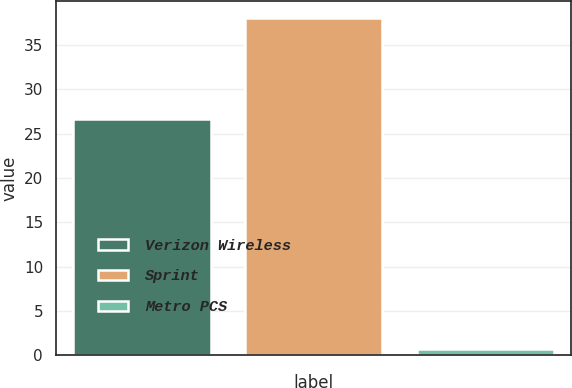Convert chart to OTSL. <chart><loc_0><loc_0><loc_500><loc_500><bar_chart><fcel>Verizon Wireless<fcel>Sprint<fcel>Metro PCS<nl><fcel>26.6<fcel>38<fcel>0.7<nl></chart> 